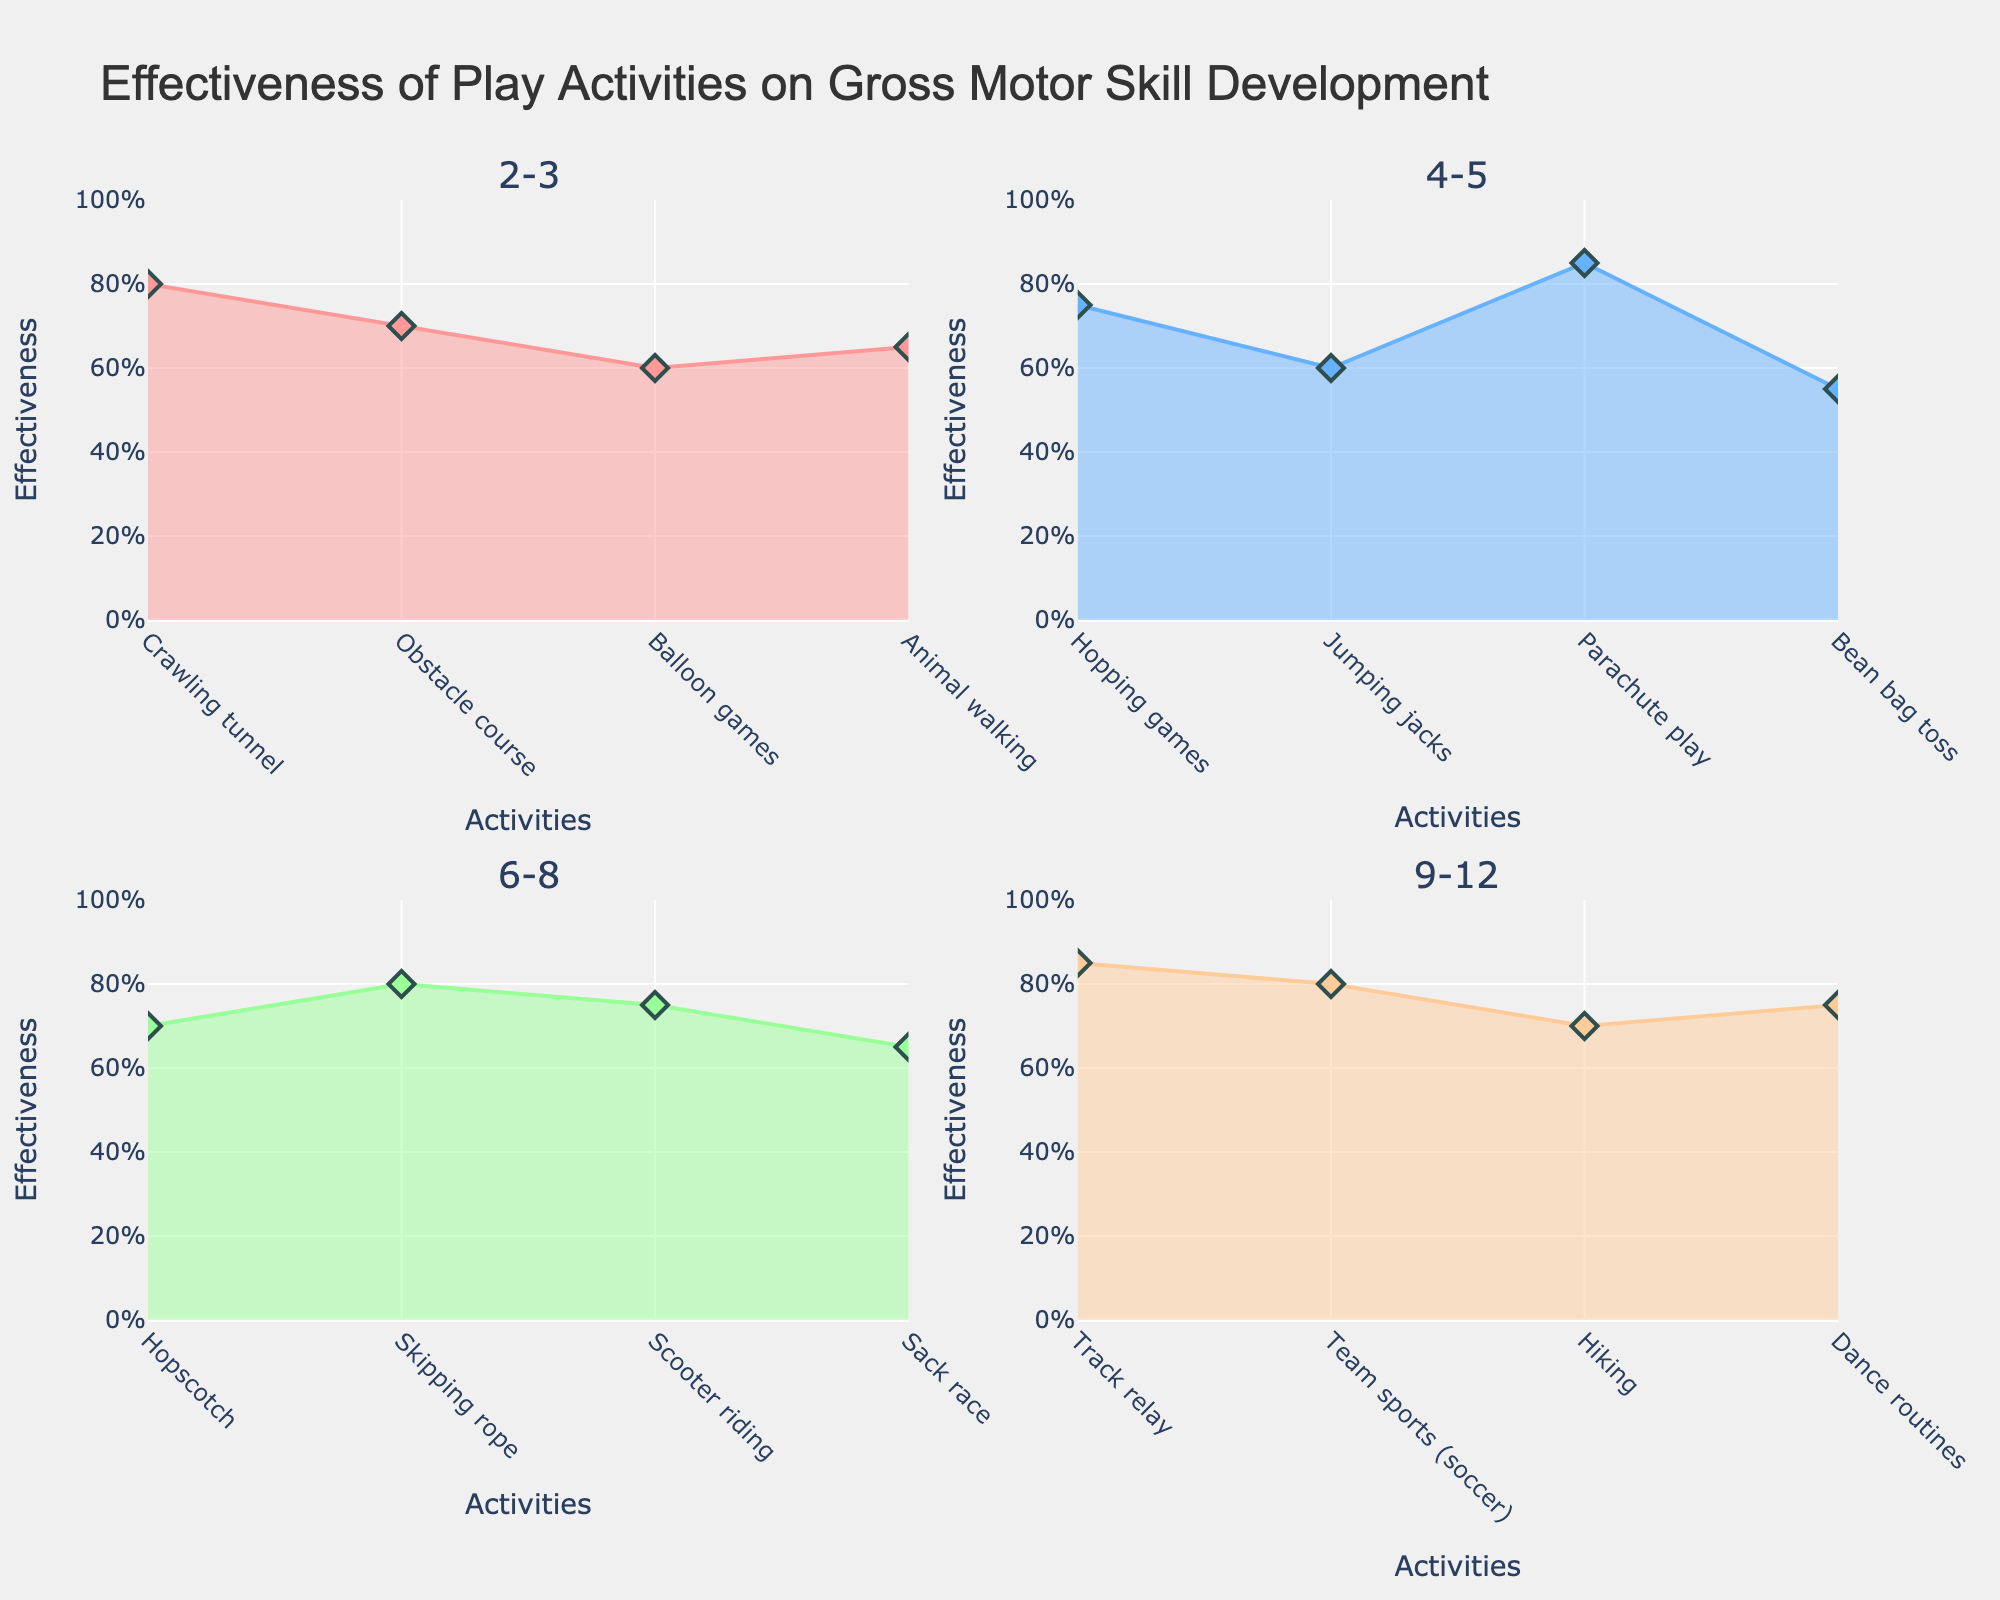Which activity has the highest effectiveness in the age group 4-5? To find the activity with the highest effectiveness, look within the subplot for age group 4-5. Parachute play has the highest effectiveness value of 0.85.
Answer: Parachute play What is the overall title of the figure? The overall title is displayed at the top of the figure. It reads "Effectiveness of Play Activities on Gross Motor Skill Development".
Answer: Effectiveness of Play Activities on Gross Motor Skill Development Which age group shows the highest effectiveness for any activity? Compare the effectiveness values across all age groups. The highest effectiveness value is 0.85, which is found in both the 4-5 age group (Parachute play) and the 9-12 age group (Track relay).
Answer: 4-5 and 9-12 Is the hopping games more effective than jumping jacks in the 4-5 age group? In the 4-5 age group subplot, observe the effectiveness values for hopping games (0.75) and jumping jacks (0.6). Compare these values directly.
Answer: Yes Which age group has the lowest average effectiveness for its activities? Calculate the average effectiveness for each age group. 2-3: (0.8 + 0.7 + 0.6 + 0.65)/4 = 0.6875, 4-5: (0.75 + 0.6 + 0.85 + 0.55)/4 = 0.6875, 6-8: (0.7 + 0.8 + 0.75 + 0.65)/4 = 0.725, 9-12: (0.85 + 0.8 + 0.7 + 0.75)/4 = 0.775. The 2-3 and 4-5 age groups have the lowest average effectiveness of 0.6875.
Answer: 2-3 and 4-5 What color represents the age group 6-8 in the plots? Identify the color used for the 6-8 age group by looking at the area chart in the respective subplot. The color is light green.
Answer: Light green Which activity is shown to be the least effective for the age group 2-3? In the age group 2-3 subplot, observe the effectiveness values and locate the lowest one. Balloon games has the lowest effectiveness value of 0.6.
Answer: Balloon games Compare the effectiveness of team sports (soccer) and dance routines in the age group 9-12. Which one is more effective? In the 9-12 age group subplot, compare the effectiveness values of team sports (soccer) (0.8) and dance routines (0.75).
Answer: Team sports (soccer) What are the y-axis labels in all the subplots indicating? The y-axis labels in all subplots indicate the effectiveness, which ranges from 0 to 1 and shows a percentage format from 0% to 100%.
Answer: Effectiveness 